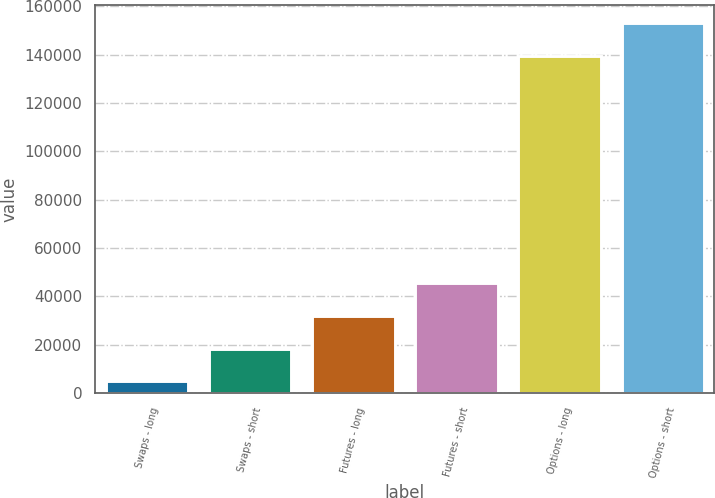Convert chart to OTSL. <chart><loc_0><loc_0><loc_500><loc_500><bar_chart><fcel>Swaps - long<fcel>Swaps - short<fcel>Futures - long<fcel>Futures - short<fcel>Options - long<fcel>Options - short<nl><fcel>4801<fcel>18389.9<fcel>31978.8<fcel>45567.7<fcel>139340<fcel>152929<nl></chart> 